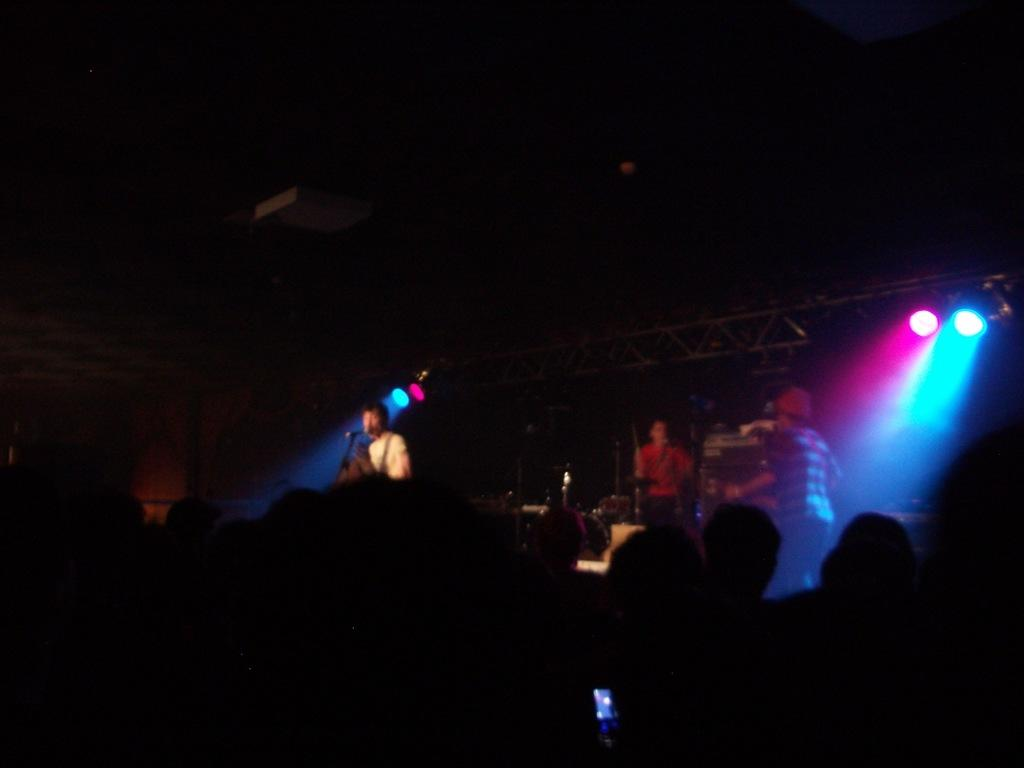What is the main subject of the image? There is a person in the image. What is the person doing in the image? The person is singing in the microphone. What additional elements can be seen in the image? There are focus lights in the image. Are there any other people visible in the image? Yes, there are people on the right side of the image. What color is the downtown area in the image? There is no downtown area present in the image. Do the people in the image believe in the power of music? The image does not provide information about the beliefs of the people in the image. 